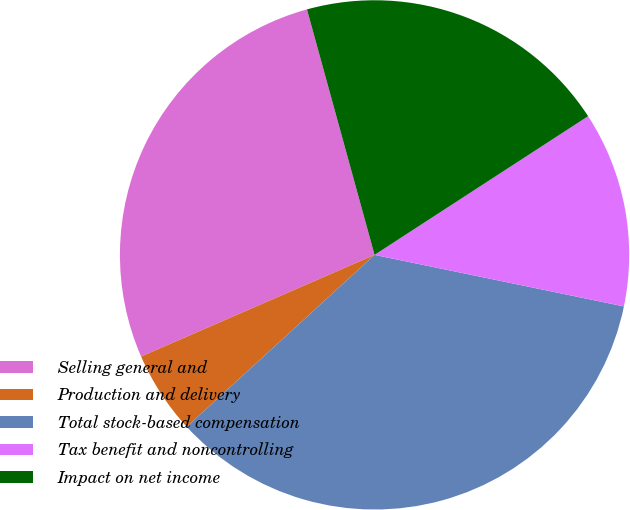Convert chart to OTSL. <chart><loc_0><loc_0><loc_500><loc_500><pie_chart><fcel>Selling general and<fcel>Production and delivery<fcel>Total stock-based compensation<fcel>Tax benefit and noncontrolling<fcel>Impact on net income<nl><fcel>27.26%<fcel>5.26%<fcel>34.96%<fcel>12.41%<fcel>20.11%<nl></chart> 